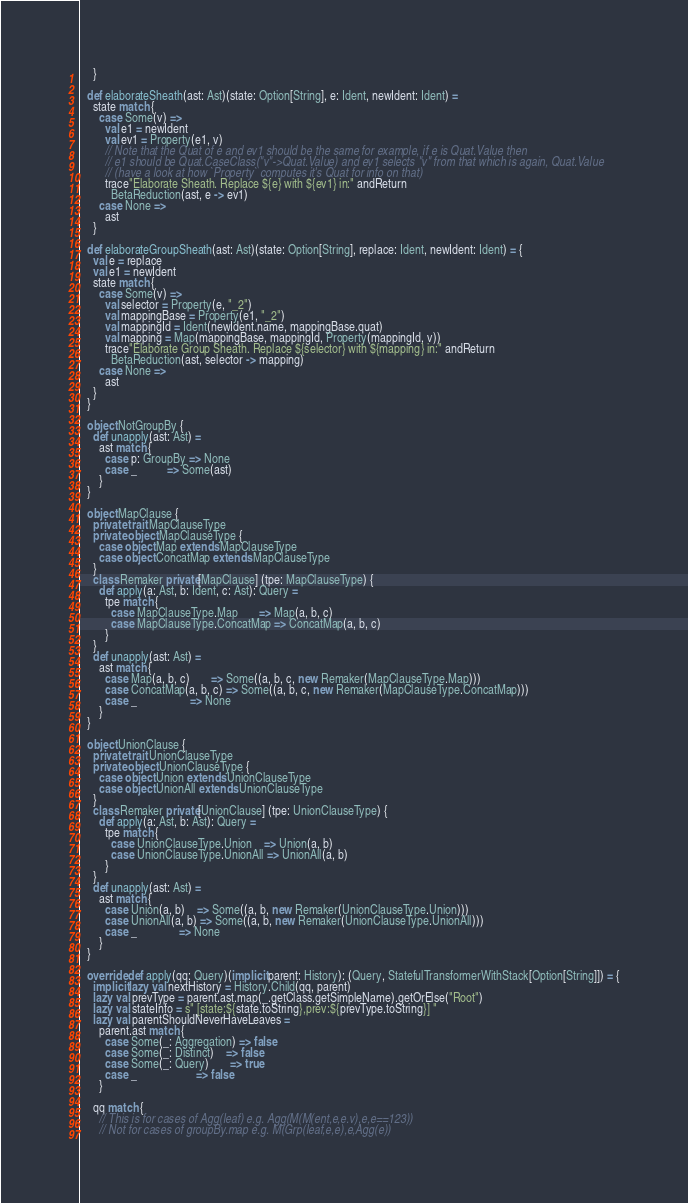Convert code to text. <code><loc_0><loc_0><loc_500><loc_500><_Scala_>    }

  def elaborateSheath(ast: Ast)(state: Option[String], e: Ident, newIdent: Ident) =
    state match {
      case Some(v) =>
        val e1 = newIdent
        val ev1 = Property(e1, v)
        // Note that the Quat of e and ev1 should be the same for example, if e is Quat.Value then
        // e1 should be Quat.CaseClass("v"->Quat.Value) and ev1 selects "v" from that which is again, Quat.Value
        // (have a look at how `Property` computes it's Quat for info on that)
        trace"Elaborate Sheath. Replace ${e} with ${ev1} in:" andReturn
          BetaReduction(ast, e -> ev1)
      case None =>
        ast
    }

  def elaborateGroupSheath(ast: Ast)(state: Option[String], replace: Ident, newIdent: Ident) = {
    val e = replace
    val e1 = newIdent
    state match {
      case Some(v) =>
        val selector = Property(e, "_2")
        val mappingBase = Property(e1, "_2")
        val mappingId = Ident(newIdent.name, mappingBase.quat)
        val mapping = Map(mappingBase, mappingId, Property(mappingId, v))
        trace"Elaborate Group Sheath. Replace ${selector} with ${mapping} in:" andReturn
          BetaReduction(ast, selector -> mapping)
      case None =>
        ast
    }
  }

  object NotGroupBy {
    def unapply(ast: Ast) =
      ast match {
        case p: GroupBy => None
        case _          => Some(ast)
      }
  }

  object MapClause {
    private trait MapClauseType
    private object MapClauseType {
      case object Map extends MapClauseType
      case object ConcatMap extends MapClauseType
    }
    class Remaker private[MapClause] (tpe: MapClauseType) {
      def apply(a: Ast, b: Ident, c: Ast): Query =
        tpe match {
          case MapClauseType.Map       => Map(a, b, c)
          case MapClauseType.ConcatMap => ConcatMap(a, b, c)
        }
    }
    def unapply(ast: Ast) =
      ast match {
        case Map(a, b, c)       => Some((a, b, c, new Remaker(MapClauseType.Map)))
        case ConcatMap(a, b, c) => Some((a, b, c, new Remaker(MapClauseType.ConcatMap)))
        case _                  => None
      }
  }

  object UnionClause {
    private trait UnionClauseType
    private object UnionClauseType {
      case object Union extends UnionClauseType
      case object UnionAll extends UnionClauseType
    }
    class Remaker private[UnionClause] (tpe: UnionClauseType) {
      def apply(a: Ast, b: Ast): Query =
        tpe match {
          case UnionClauseType.Union    => Union(a, b)
          case UnionClauseType.UnionAll => UnionAll(a, b)
        }
    }
    def unapply(ast: Ast) =
      ast match {
        case Union(a, b)    => Some((a, b, new Remaker(UnionClauseType.Union)))
        case UnionAll(a, b) => Some((a, b, new Remaker(UnionClauseType.UnionAll)))
        case _              => None
      }
  }

  override def apply(qq: Query)(implicit parent: History): (Query, StatefulTransformerWithStack[Option[String]]) = {
    implicit lazy val nextHistory = History.Child(qq, parent)
    lazy val prevType = parent.ast.map(_.getClass.getSimpleName).getOrElse("Root")
    lazy val stateInfo = s" [state:${state.toString},prev:${prevType.toString}] "
    lazy val parentShouldNeverHaveLeaves =
      parent.ast match {
        case Some(_: Aggregation) => false
        case Some(_: Distinct)    => false
        case Some(_: Query)       => true
        case _                    => false
      }

    qq match {
      // This is for cases of Agg(leaf) e.g. Agg(M(M(ent,e,e.v),e,e==123))
      // Not for cases of groupBy.map e.g. M(Grp(leaf,e,e),e,Agg(e))</code> 